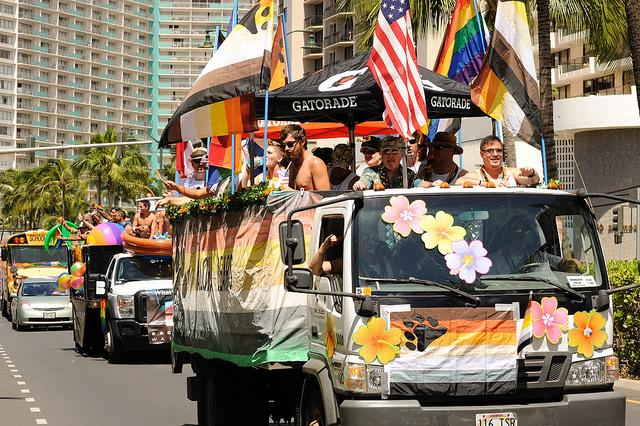Which company manufactures this beverage? gatorade 